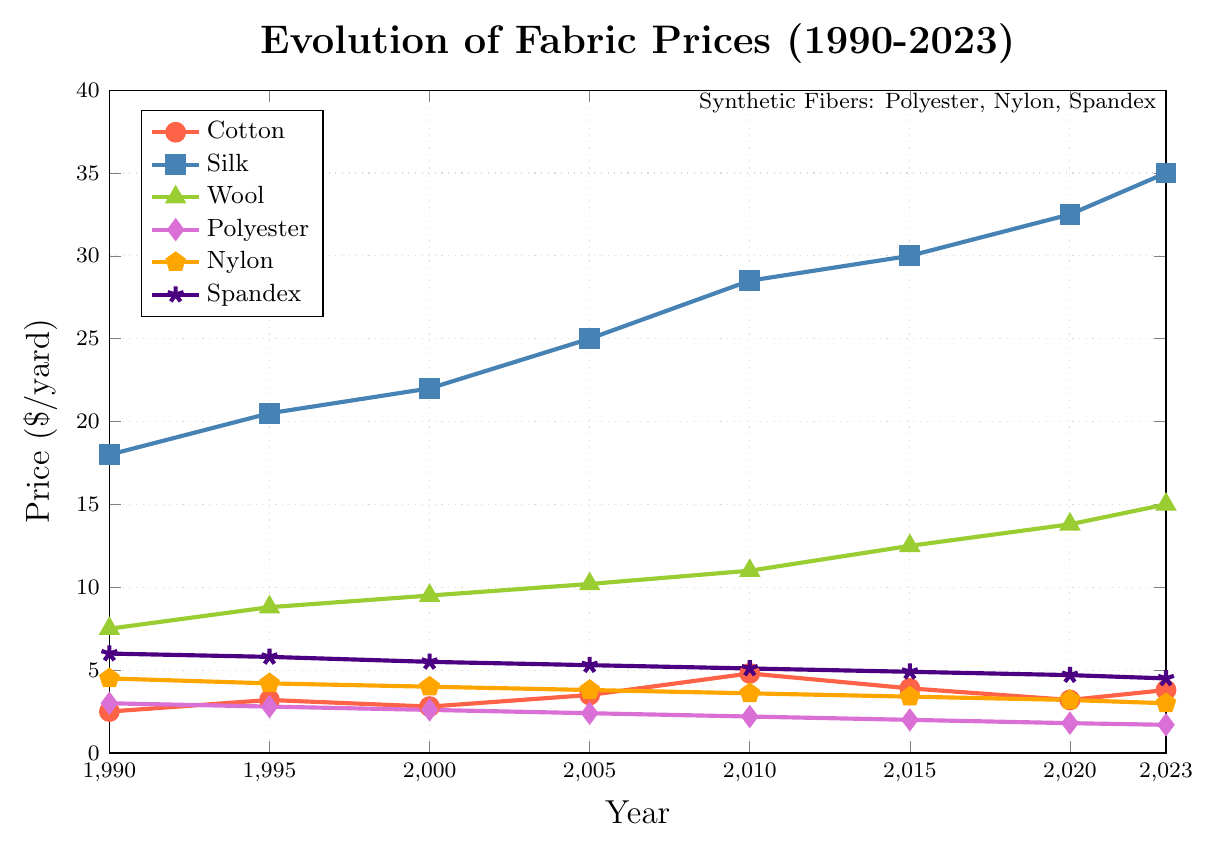What is the general trend for silk prices from 1990 to 2023? To determine the trend, observe the data points for silk prices at each year. The prices start at $18.00 in 1990 and steadily increase to $35.00 by 2023. This indicates a consistent upward trend over the years.
Answer: Upward trend Which fabric had the highest price in 2023? To answer this, visually identify the highest data point in the 2023 column. Silk is at $35.00, which is the highest price among all the fabrics in that year.
Answer: Silk How much did the price of polyester decrease from 1990 to 2020? Compare the polyester price in 1990 ($3.00) with the price in 2020 ($1.80), and calculate the difference (3.00 - 1.80).
Answer: $1.20 Between wool and spandex, which fabric had a higher price in 2010, and by how much? Look at the 2010 data points for wool ($11.00) and spandex ($5.10). Subtract the price of spandex from wool (11.00 - 5.10). Wool had a higher price by $5.90 in 2010.
Answer: Wool, $5.90 What is the average price of cotton across all recorded years? Sum up all the cotton prices from 1990 to 2023 (2.50 + 3.20 + 2.80 + 3.50 + 4.80 + 3.90 + 3.20 + 3.80) and divide by the number of years (8). The sum is 27.70, so the average is 27.70/8.
Answer: $3.46 Compare the price trends of natural fibers (cotton, silk, and wool) with synthetic fibers (polyester, nylon, and spandex). What differences do you observe? Observe the trend lines for both natural and synthetic fibers. Natural fibers (cotton, silk, and wool) generally show an upward trend, while synthetic fibers (polyester, nylon, and spandex) show a downward or relatively stable trend over the years.
Answer: Natural fibers increase, synthetic fibers decrease or stable Which year did the price of wool reach $10.20? Identify the data point where wool has the value $10.20, which is in the year 2005.
Answer: 2005 Which fabric shows the most consistent decrease in price from 1990 to 2023? After examining the plot, it is clear that polyester shows a consistent decrease in price from $3.00 in 1990 to $1.70 in 2023.
Answer: Polyester In 1995, how much more expensive was silk compared to cotton? Look at the prices in 1995 for silk ($20.50) and cotton ($3.20). Subtract the cotton price from the silk price (20.50 - 3.20).
Answer: $17.30 If you were designing a period costume requiring silk, during which year would your material costs have been the lowest based on this data? The lowest silk price from the given years is in 1990, at $18.00.
Answer: 1990 